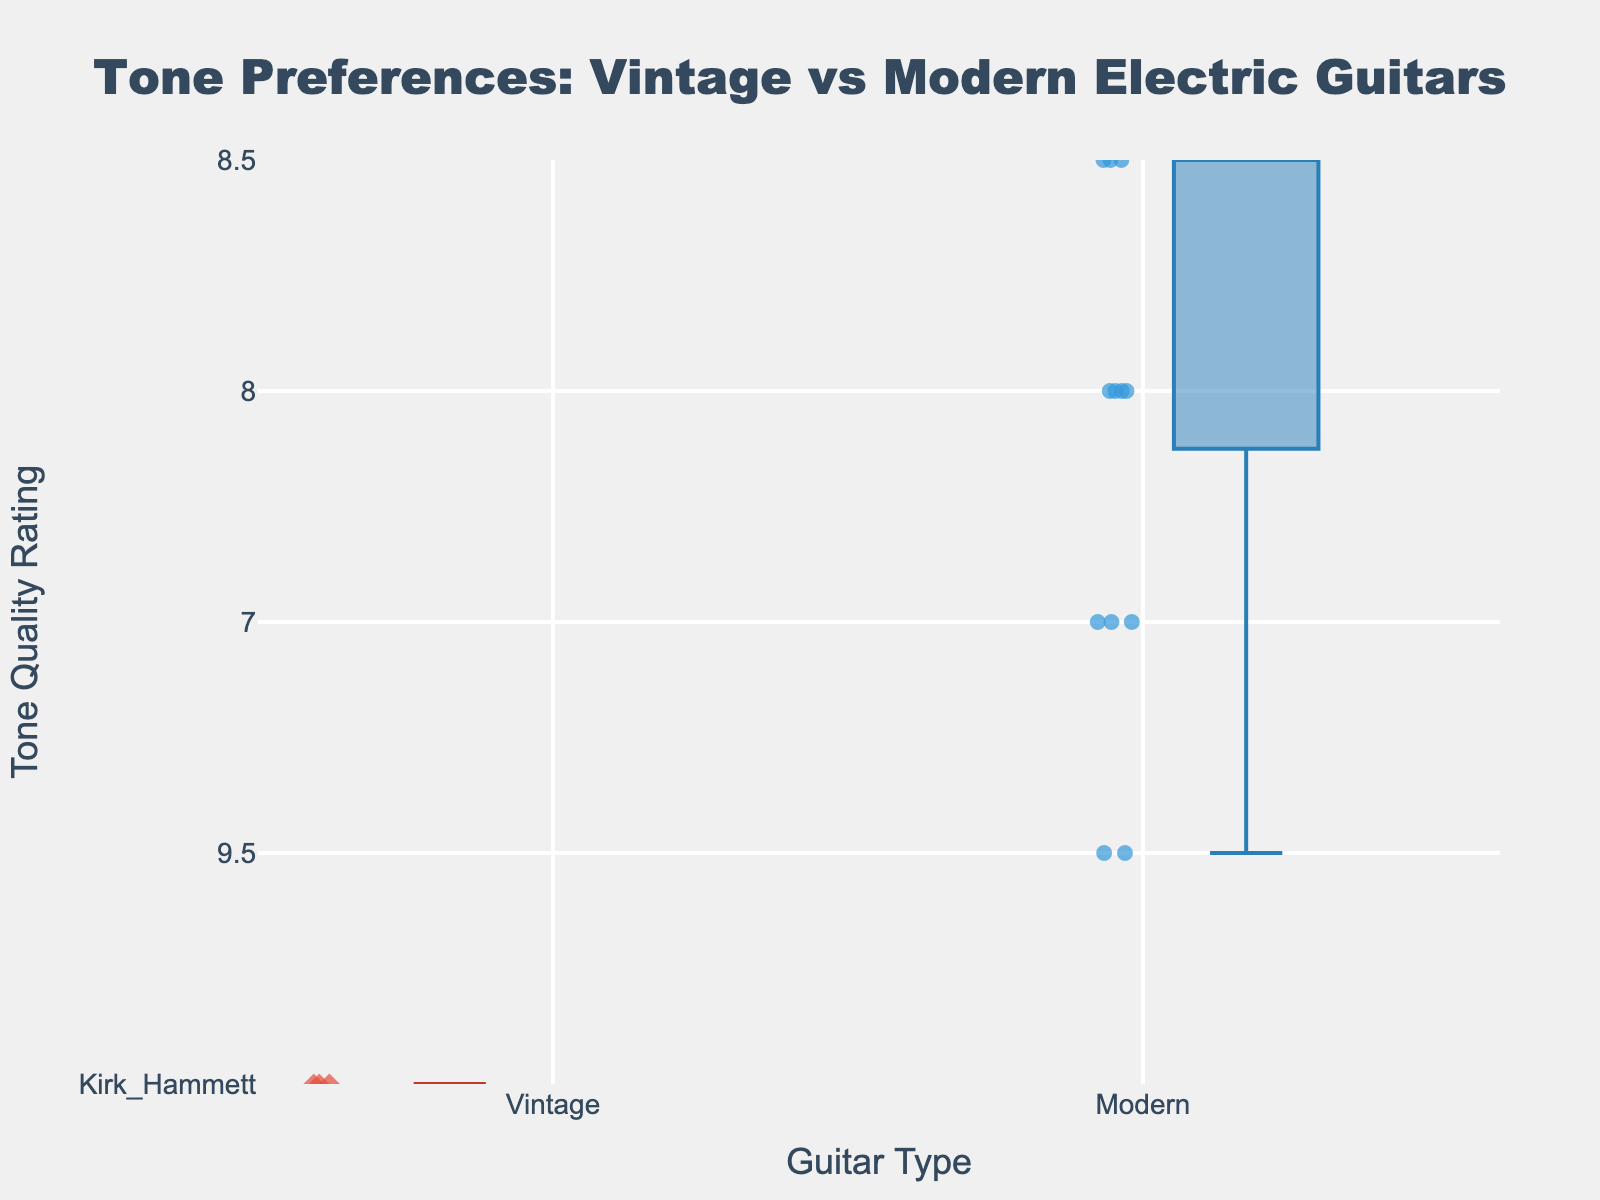What's the title of the plot? The figure's title can be found at the top centre of the plot. It reads, "Tone Preferences: Vintage vs Modern Electric Guitars."
Answer: Tone Preferences: Vintage vs Modern Electric Guitars What are the groups being compared in this plot? The groups being compared can be determined by the category names on the x-axis, which are labeled "Vintage" and "Modern."
Answer: Vintage and Modern What is the y-axis representing? The y-axis represents the tone quality ratings of the guitars. The label on the y-axis reads "Tone Quality Rating."
Answer: Tone Quality Rating How many data points are there for the Modern guitar group? Each marker in the "Modern" box represents a data point. By counting all the markers within the Modern box, we find there are 7 data points.
Answer: 7 What is the median value for the Vintage guitar group? The median value can be found by looking at the line inside the Vintage box, which appears to be very close to 8.7.
Answer: ~8.7 Which guitar group has the higher maximum tone quality rating? By looking at the whiskers (vertical lines) of each box, the Vintage group has a higher maximum value, reaching just below 10, whereas the Modern group doesn't surpass 9.5.
Answer: Vintage What is the range of the tone quality ratings for Vintage guitars? The range can be calculated by subtracting the minimum value from the maximum value for the Vintage group. The whiskers indicate the maximum is just below 10 and the minimum is about 8.
Answer: ~2 What is the interquartile range (IQR) of the tone quality ratings for Modern guitars? The IQR is the difference between the third quartile (top of the box) and the first quartile (bottom of the box) of the Modern group. The box seems to stretch from ~7.5 to ~9.0.
Answer: ~1.5 Are ratings for Vintage guitars generally higher than Modern guitars? Comparing the median lines and the overall position of the boxes, the Vintage guitar group has higher overall and median ratings than the Modern guitar group.
Answer: Yes What is the approximate lowest tone quality rating for Modern guitars? The lowest rating for Modern guitars can be determined by the bottom whisker of the Modern box, which is close to 7.
Answer: ~7 